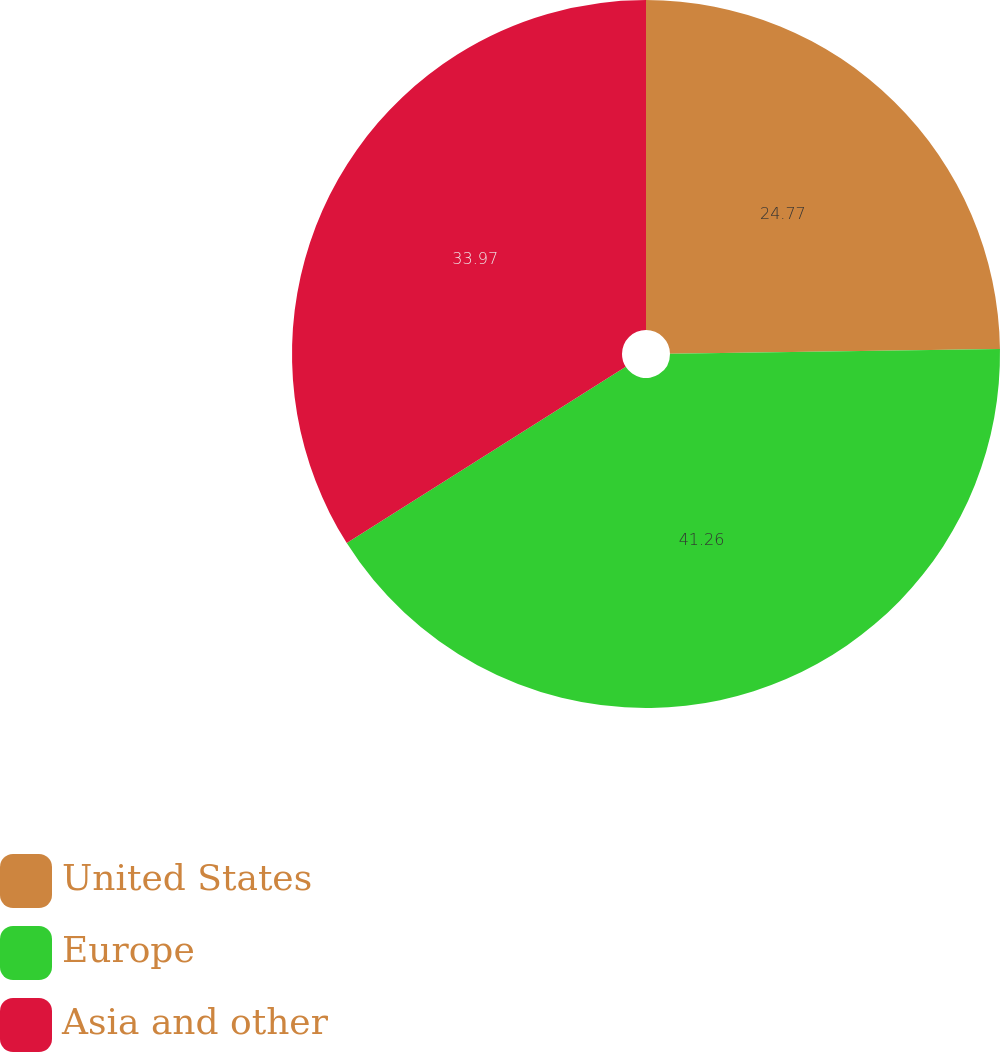<chart> <loc_0><loc_0><loc_500><loc_500><pie_chart><fcel>United States<fcel>Europe<fcel>Asia and other<nl><fcel>24.77%<fcel>41.26%<fcel>33.97%<nl></chart> 